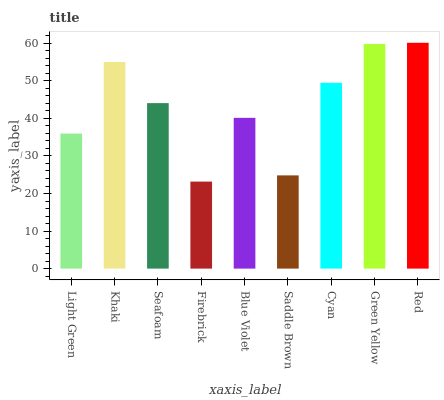Is Firebrick the minimum?
Answer yes or no. Yes. Is Red the maximum?
Answer yes or no. Yes. Is Khaki the minimum?
Answer yes or no. No. Is Khaki the maximum?
Answer yes or no. No. Is Khaki greater than Light Green?
Answer yes or no. Yes. Is Light Green less than Khaki?
Answer yes or no. Yes. Is Light Green greater than Khaki?
Answer yes or no. No. Is Khaki less than Light Green?
Answer yes or no. No. Is Seafoam the high median?
Answer yes or no. Yes. Is Seafoam the low median?
Answer yes or no. Yes. Is Cyan the high median?
Answer yes or no. No. Is Light Green the low median?
Answer yes or no. No. 